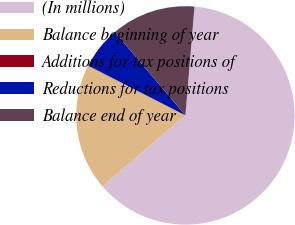Convert chart to OTSL. <chart><loc_0><loc_0><loc_500><loc_500><pie_chart><fcel>(In millions)<fcel>Balance beginning of year<fcel>Additions for tax positions of<fcel>Reductions for tax positions<fcel>Balance end of year<nl><fcel>62.43%<fcel>18.75%<fcel>0.03%<fcel>6.27%<fcel>12.51%<nl></chart> 